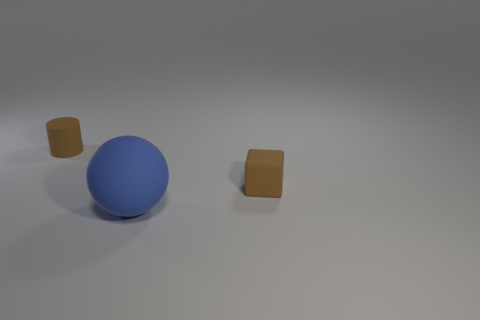Is the number of blue balls that are to the right of the large matte thing less than the number of rubber spheres?
Provide a succinct answer. Yes. What is the size of the thing in front of the tiny brown cube?
Provide a succinct answer. Large. There is a brown cylinder that is the same material as the brown block; what size is it?
Offer a terse response. Small. Is the number of small blocks less than the number of large purple rubber blocks?
Provide a short and direct response. No. What material is the brown cube that is the same size as the brown cylinder?
Provide a short and direct response. Rubber. Are there more red rubber cubes than small brown rubber cylinders?
Keep it short and to the point. No. What number of other things are the same color as the tiny matte cylinder?
Make the answer very short. 1. What number of matte objects are both behind the blue rubber ball and in front of the tiny brown matte cylinder?
Your answer should be compact. 1. Are there any other things that are the same size as the sphere?
Make the answer very short. No. Are there more blue rubber balls behind the small rubber cylinder than brown cubes that are on the left side of the brown rubber cube?
Ensure brevity in your answer.  No. 